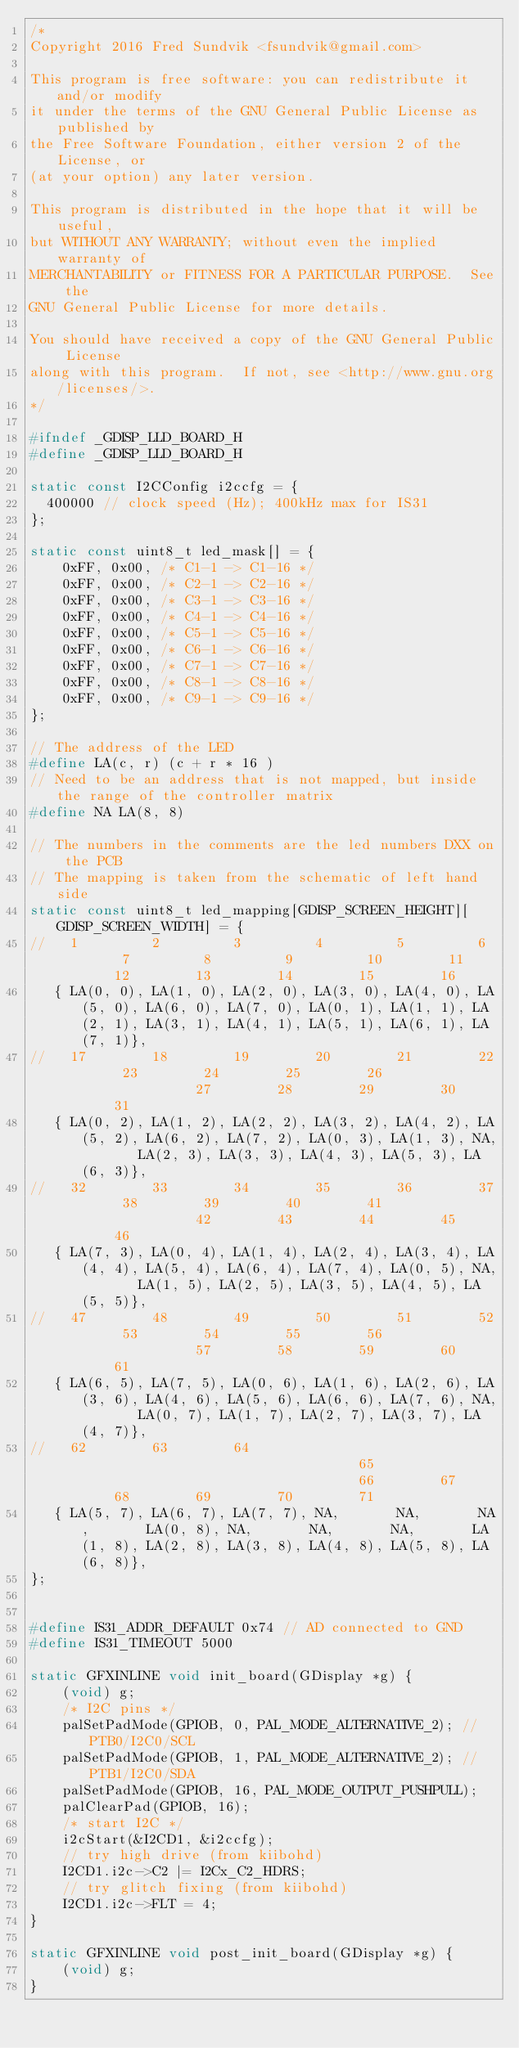Convert code to text. <code><loc_0><loc_0><loc_500><loc_500><_C_>/*
Copyright 2016 Fred Sundvik <fsundvik@gmail.com>

This program is free software: you can redistribute it and/or modify
it under the terms of the GNU General Public License as published by
the Free Software Foundation, either version 2 of the License, or
(at your option) any later version.

This program is distributed in the hope that it will be useful,
but WITHOUT ANY WARRANTY; without even the implied warranty of
MERCHANTABILITY or FITNESS FOR A PARTICULAR PURPOSE.  See the
GNU General Public License for more details.

You should have received a copy of the GNU General Public License
along with this program.  If not, see <http://www.gnu.org/licenses/>.
*/

#ifndef _GDISP_LLD_BOARD_H
#define _GDISP_LLD_BOARD_H

static const I2CConfig i2ccfg = {
  400000 // clock speed (Hz); 400kHz max for IS31
};

static const uint8_t led_mask[] = {
	0xFF, 0x00, /* C1-1 -> C1-16 */
	0xFF, 0x00, /* C2-1 -> C2-16 */
	0xFF, 0x00, /* C3-1 -> C3-16 */
	0xFF, 0x00, /* C4-1 -> C4-16 */
	0xFF, 0x00, /* C5-1 -> C5-16 */
	0xFF, 0x00, /* C6-1 -> C6-16 */
	0xFF, 0x00, /* C7-1 -> C7-16 */
	0xFF, 0x00, /* C8-1 -> C8-16 */
	0xFF, 0x00, /* C9-1 -> C9-16 */
};

// The address of the LED
#define LA(c, r) (c + r * 16 )
// Need to be an address that is not mapped, but inside the range of the controller matrix
#define NA LA(8, 8)

// The numbers in the comments are the led numbers DXX on the PCB
// The mapping is taken from the schematic of left hand side
static const uint8_t led_mapping[GDISP_SCREEN_HEIGHT][GDISP_SCREEN_WIDTH] = {
//   1         2         3         4         5         6         7         8         9         10        11        12        13        14        15        16
   { LA(0, 0), LA(1, 0), LA(2, 0), LA(3, 0), LA(4, 0), LA(5, 0), LA(6, 0), LA(7, 0), LA(0, 1), LA(1, 1), LA(2, 1), LA(3, 1), LA(4, 1), LA(5, 1), LA(6, 1), LA(7, 1)},
//   17        18        19        20        21        22        23        24        25        26                  27        28        29        30        31
   { LA(0, 2), LA(1, 2), LA(2, 2), LA(3, 2), LA(4, 2), LA(5, 2), LA(6, 2), LA(7, 2), LA(0, 3), LA(1, 3), NA,       LA(2, 3), LA(3, 3), LA(4, 3), LA(5, 3), LA(6, 3)},
//   32        33        34        35        36        37        38        39        40        41                  42        43        44        45        46
   { LA(7, 3), LA(0, 4), LA(1, 4), LA(2, 4), LA(3, 4), LA(4, 4), LA(5, 4), LA(6, 4), LA(7, 4), LA(0, 5), NA,       LA(1, 5), LA(2, 5), LA(3, 5), LA(4, 5), LA(5, 5)},
//   47        48        49        50        51        52        53        54        55        56                  57        58        59        60        61
   { LA(6, 5), LA(7, 5), LA(0, 6), LA(1, 6), LA(2, 6), LA(3, 6), LA(4, 6), LA(5, 6), LA(6, 6), LA(7, 6), NA,       LA(0, 7), LA(1, 7), LA(2, 7), LA(3, 7), LA(4, 7)},
//   62        63        64                                      65                                      66        67        68        69        70        71
   { LA(5, 7), LA(6, 7), LA(7, 7), NA,       NA,       NA,       LA(0, 8), NA,       NA,       NA,       LA(1, 8), LA(2, 8), LA(3, 8), LA(4, 8), LA(5, 8), LA(6, 8)},
};


#define IS31_ADDR_DEFAULT 0x74 // AD connected to GND
#define IS31_TIMEOUT 5000

static GFXINLINE void init_board(GDisplay *g) {
    (void) g;
    /* I2C pins */
    palSetPadMode(GPIOB, 0, PAL_MODE_ALTERNATIVE_2); // PTB0/I2C0/SCL
    palSetPadMode(GPIOB, 1, PAL_MODE_ALTERNATIVE_2); // PTB1/I2C0/SDA
    palSetPadMode(GPIOB, 16, PAL_MODE_OUTPUT_PUSHPULL);
    palClearPad(GPIOB, 16);
    /* start I2C */
    i2cStart(&I2CD1, &i2ccfg);
    // try high drive (from kiibohd)
    I2CD1.i2c->C2 |= I2Cx_C2_HDRS;
    // try glitch fixing (from kiibohd)
    I2CD1.i2c->FLT = 4;
}

static GFXINLINE void post_init_board(GDisplay *g) {
	(void) g;
}
</code> 